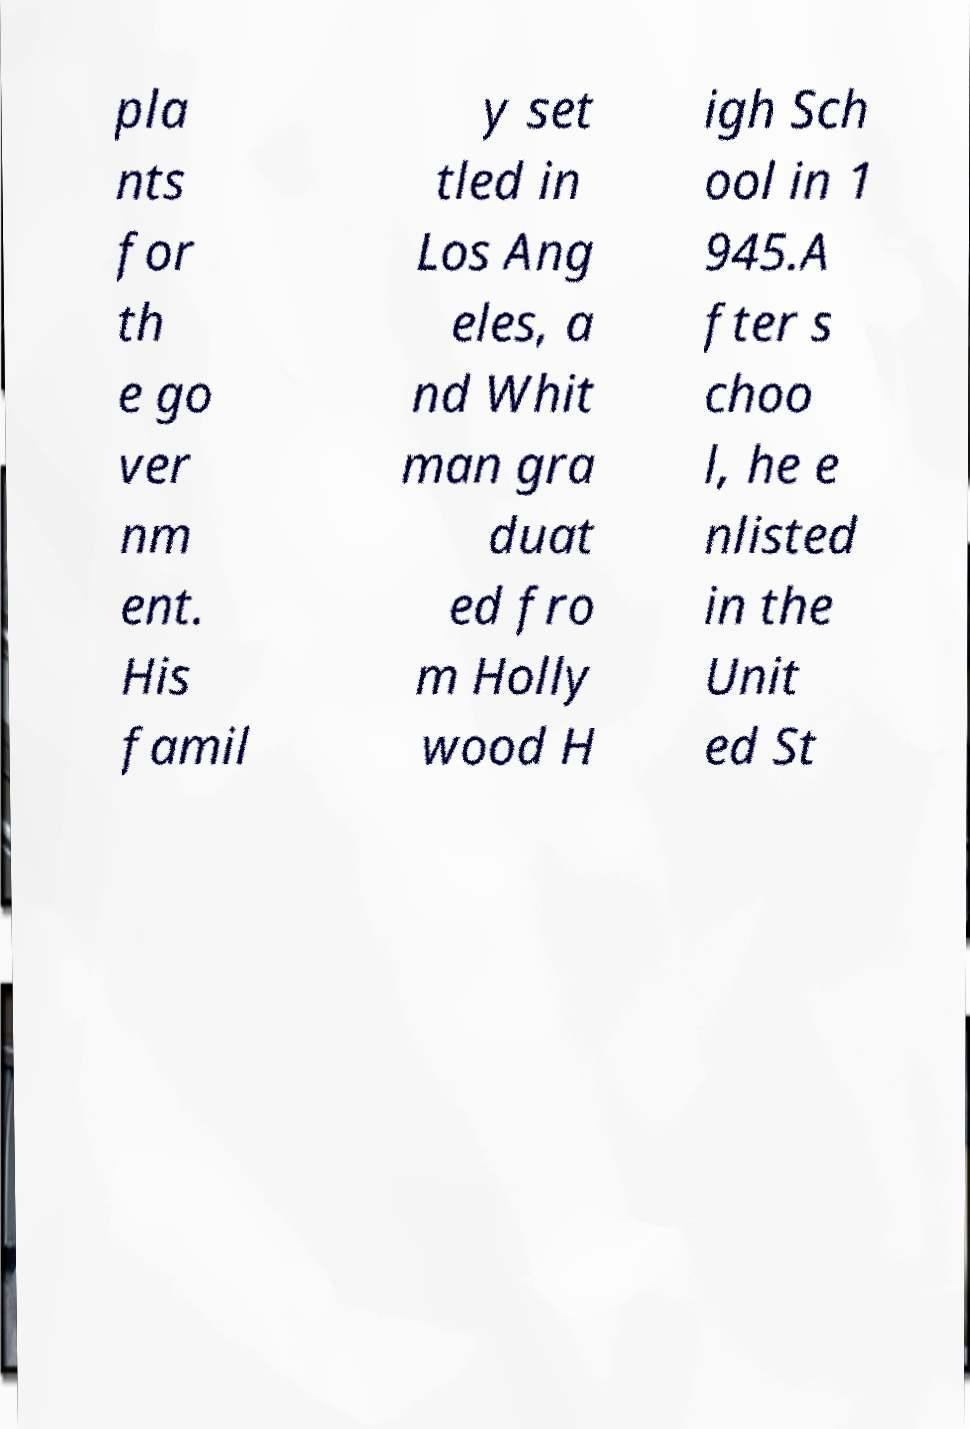Can you read and provide the text displayed in the image?This photo seems to have some interesting text. Can you extract and type it out for me? pla nts for th e go ver nm ent. His famil y set tled in Los Ang eles, a nd Whit man gra duat ed fro m Holly wood H igh Sch ool in 1 945.A fter s choo l, he e nlisted in the Unit ed St 